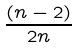<formula> <loc_0><loc_0><loc_500><loc_500>\frac { ( n - 2 ) } { 2 n }</formula> 